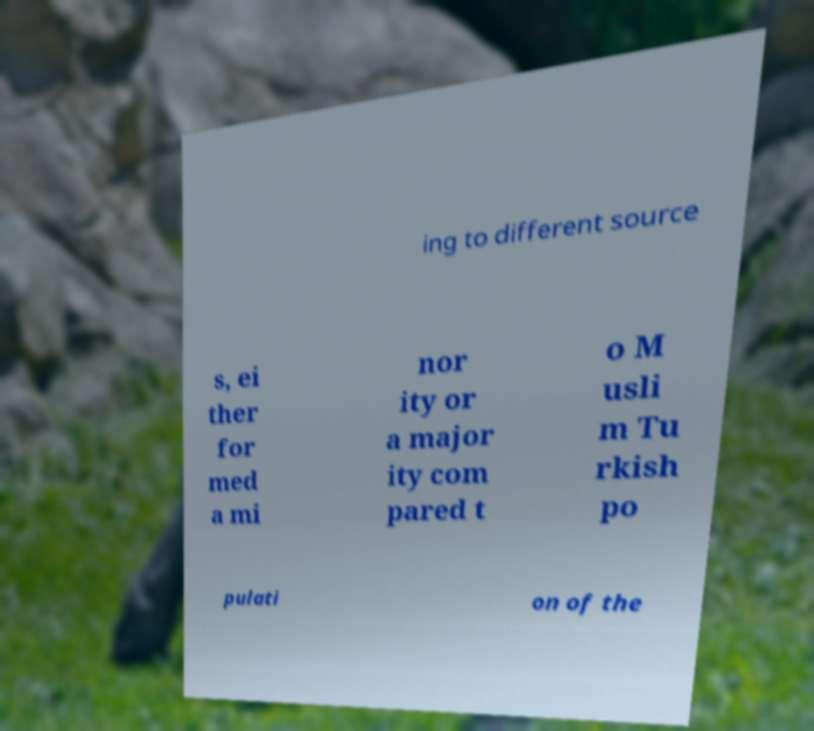Please read and relay the text visible in this image. What does it say? ing to different source s, ei ther for med a mi nor ity or a major ity com pared t o M usli m Tu rkish po pulati on of the 